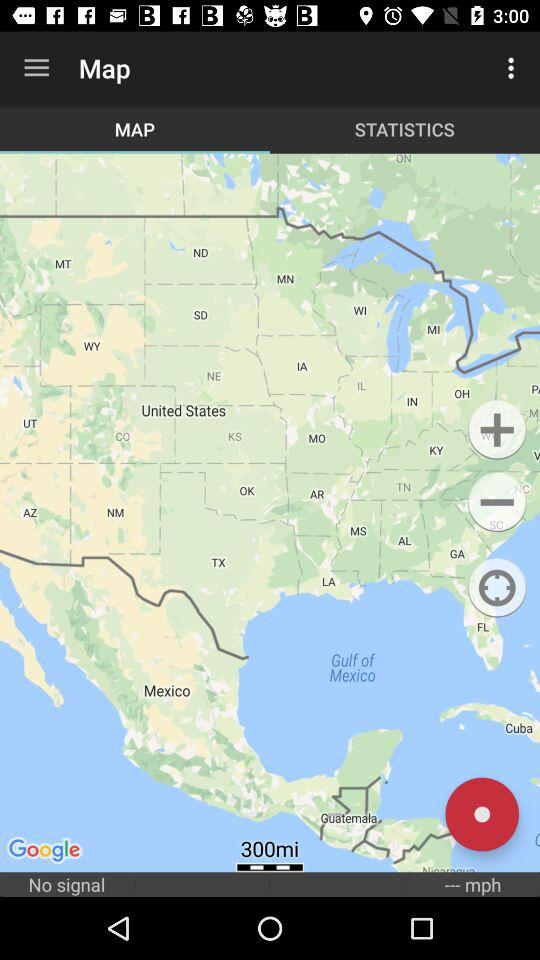What's the displayed distance? The displayed distance is 300 miles. 